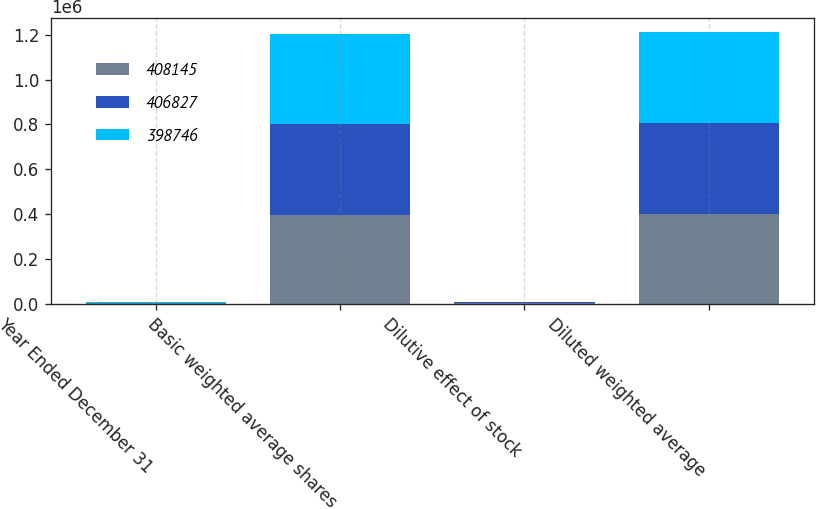Convert chart. <chart><loc_0><loc_0><loc_500><loc_500><stacked_bar_chart><ecel><fcel>Year Ended December 31<fcel>Basic weighted average shares<fcel>Dilutive effect of stock<fcel>Diluted weighted average<nl><fcel>408145<fcel>2008<fcel>396238<fcel>2508<fcel>398746<nl><fcel>406827<fcel>2007<fcel>404417<fcel>3728<fcel>408145<nl><fcel>398746<fcel>2006<fcel>403424<fcel>3403<fcel>406827<nl></chart> 